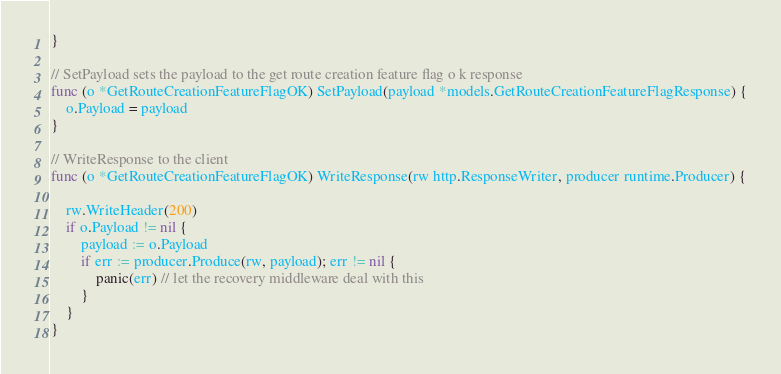Convert code to text. <code><loc_0><loc_0><loc_500><loc_500><_Go_>}

// SetPayload sets the payload to the get route creation feature flag o k response
func (o *GetRouteCreationFeatureFlagOK) SetPayload(payload *models.GetRouteCreationFeatureFlagResponse) {
	o.Payload = payload
}

// WriteResponse to the client
func (o *GetRouteCreationFeatureFlagOK) WriteResponse(rw http.ResponseWriter, producer runtime.Producer) {

	rw.WriteHeader(200)
	if o.Payload != nil {
		payload := o.Payload
		if err := producer.Produce(rw, payload); err != nil {
			panic(err) // let the recovery middleware deal with this
		}
	}
}
</code> 